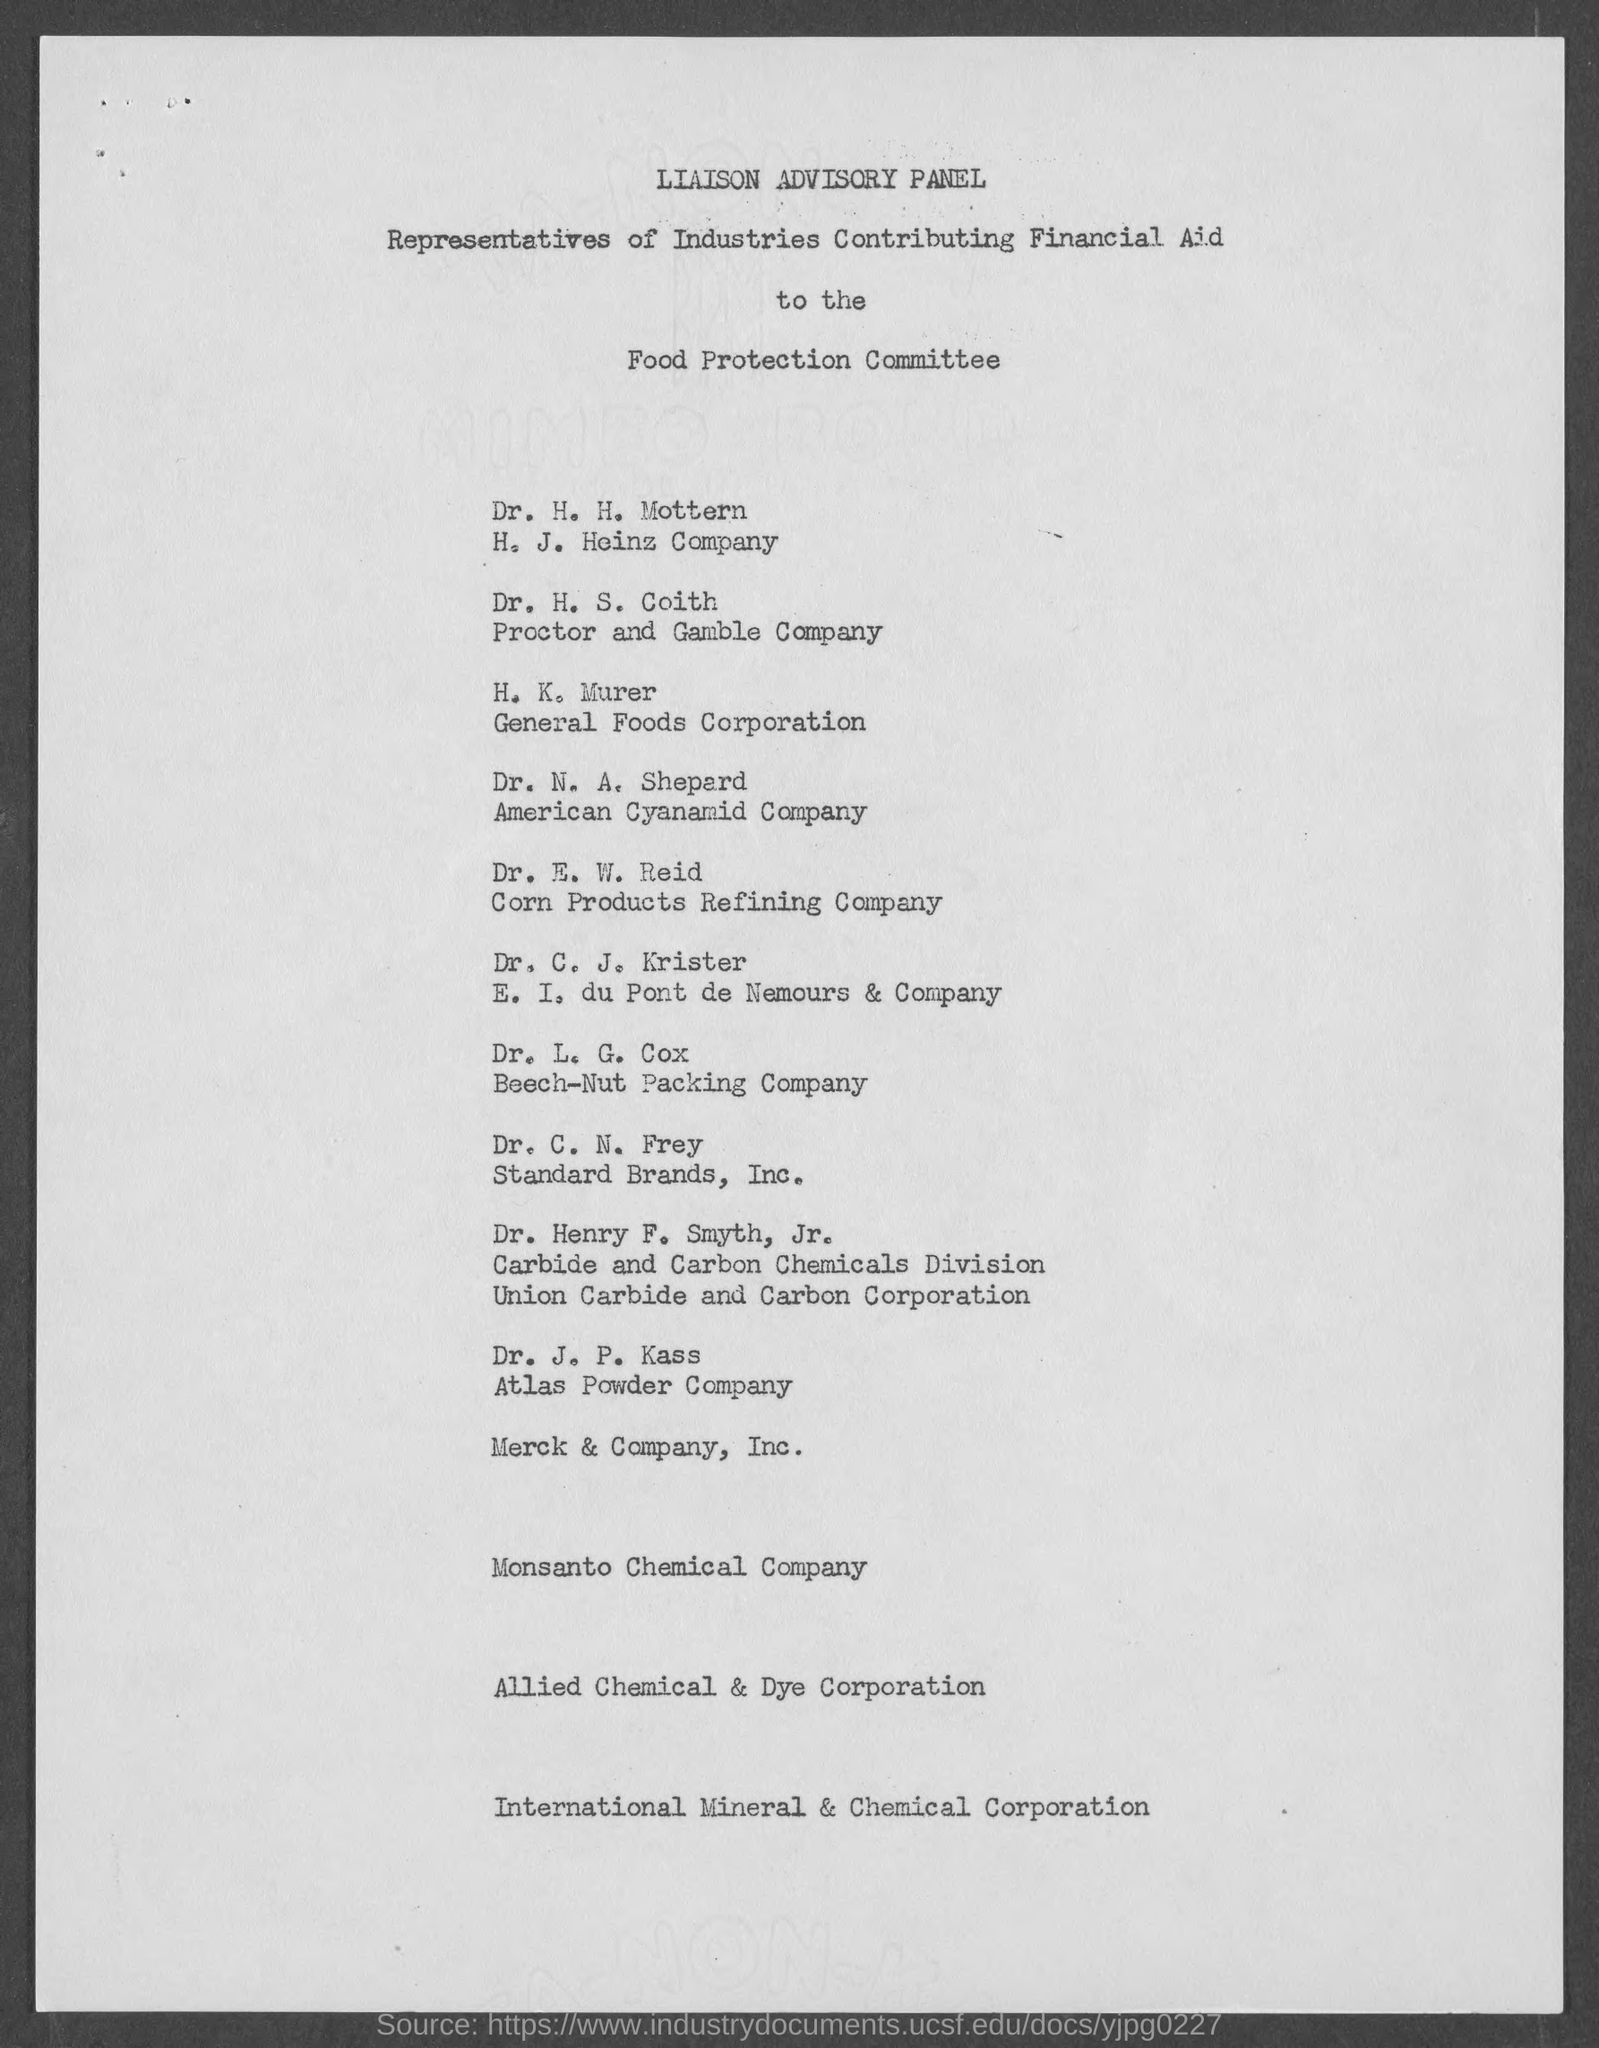What is the first title in the document?
Provide a succinct answer. Liaison Advisory Panel. What is the second title in the document?
Your answer should be very brief. Representatives of Industries Contributing Financial Aid. Dr.J.P.Kass is from which company?
Your answer should be very brief. Atlas Powder Company. C.N.Frey is from which company?
Your answer should be very brief. Standard Brands, Inc. N.A.Sheperd is from which company?
Provide a succinct answer. American Cyanamid Company. 